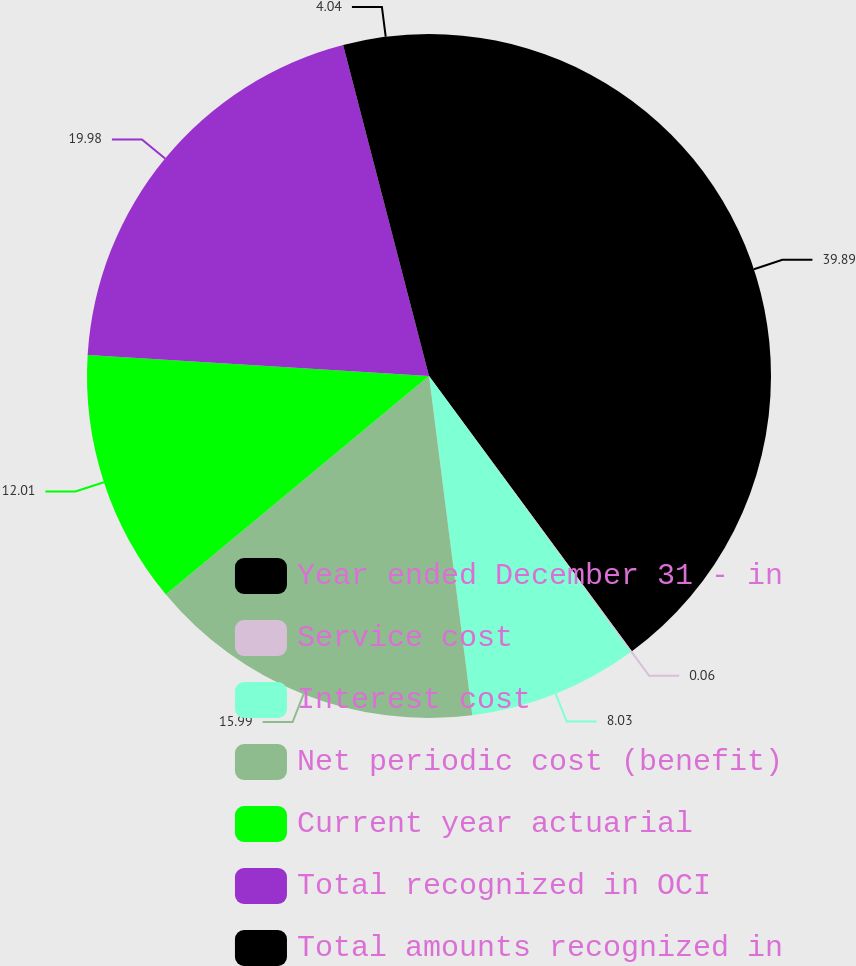<chart> <loc_0><loc_0><loc_500><loc_500><pie_chart><fcel>Year ended December 31 - in<fcel>Service cost<fcel>Interest cost<fcel>Net periodic cost (benefit)<fcel>Current year actuarial<fcel>Total recognized in OCI<fcel>Total amounts recognized in<nl><fcel>39.89%<fcel>0.06%<fcel>8.03%<fcel>15.99%<fcel>12.01%<fcel>19.98%<fcel>4.04%<nl></chart> 